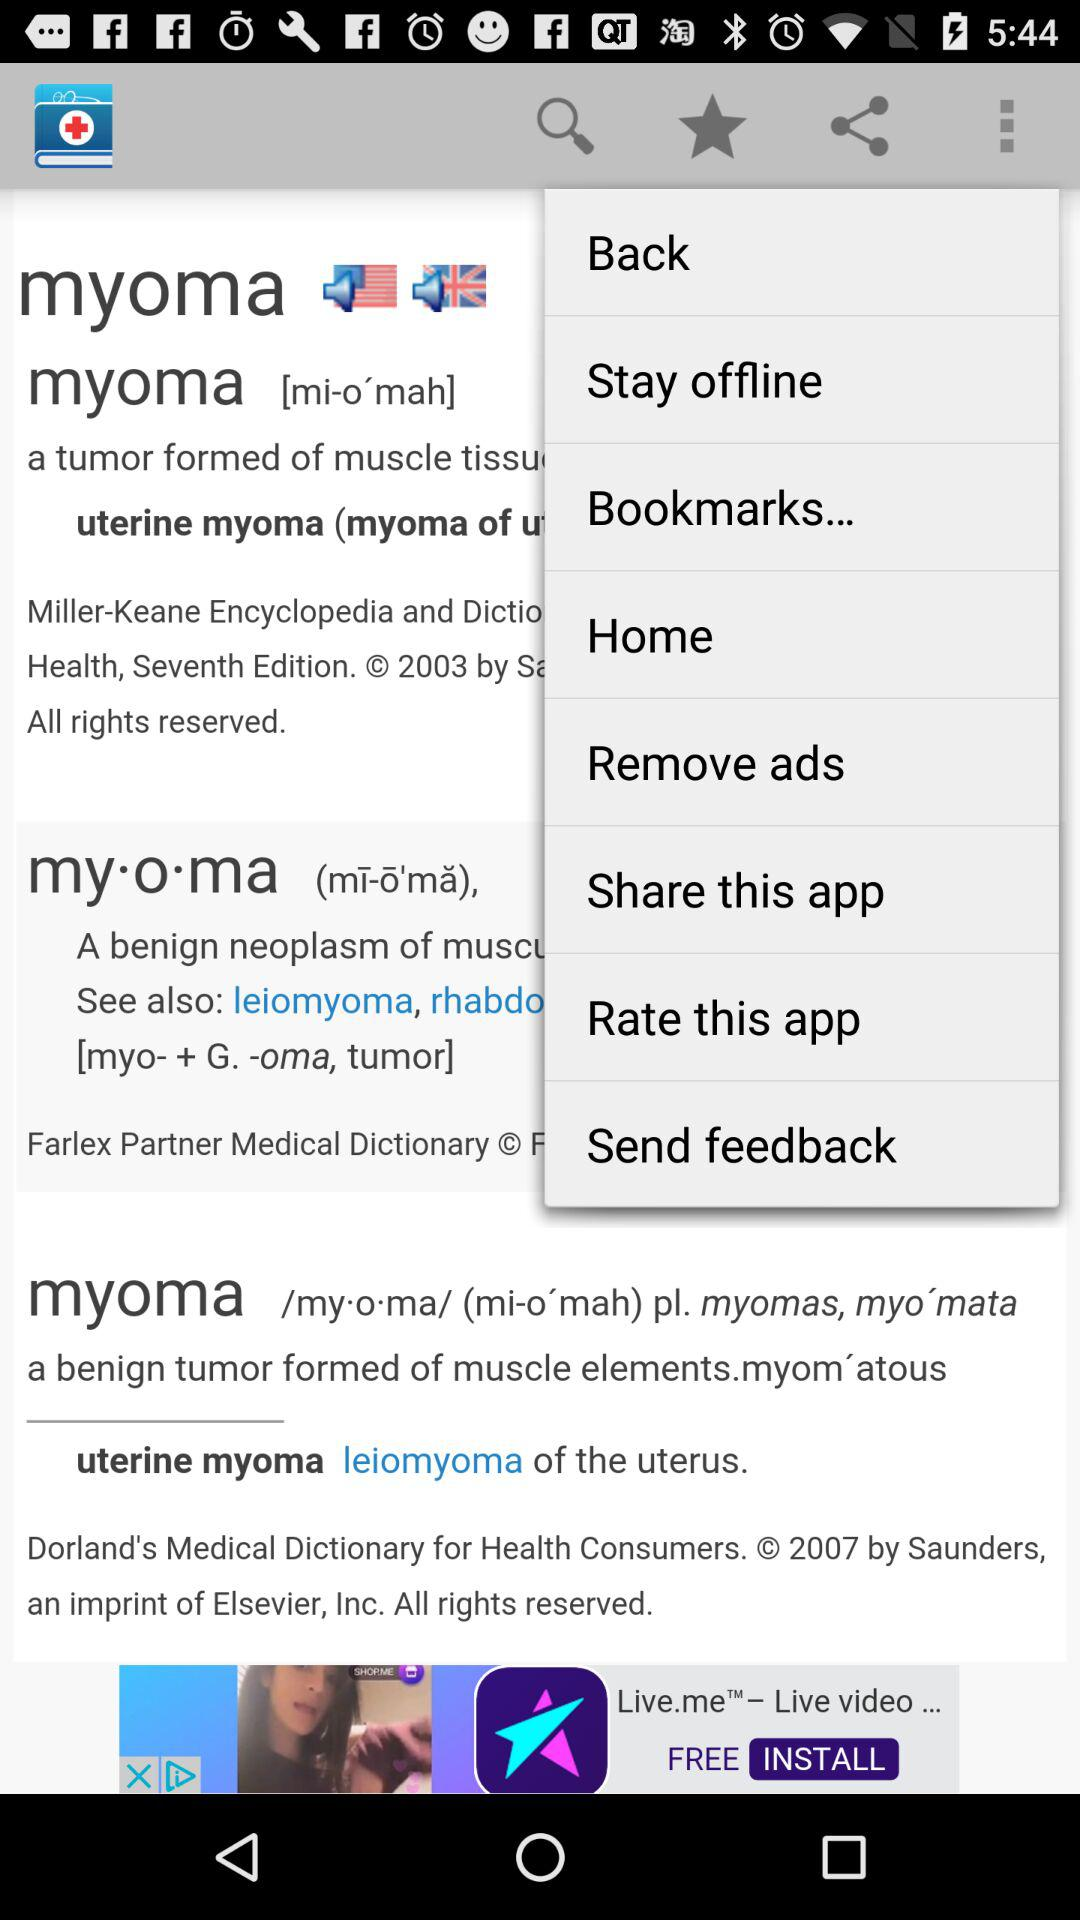Are there any interactive elements visible on the smartphone screen? Yes, the smartphone screen displays interactive elements such as the options to go 'Back', 'Stay offline', access 'Bookmarks...', visit 'Home', 'Remove ads', 'Share this app', 'Rate this app', and 'Send feedback'. 